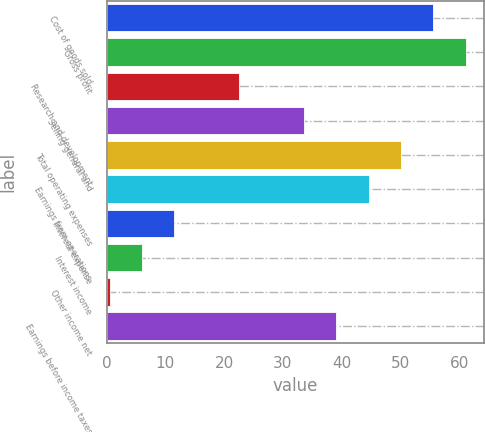<chart> <loc_0><loc_0><loc_500><loc_500><bar_chart><fcel>Cost of goods sold<fcel>Gross profit<fcel>Research and development<fcel>Selling general and<fcel>Total operating expenses<fcel>Earnings from operations<fcel>Interest expense<fcel>Interest income<fcel>Other income net<fcel>Earnings before income taxes<nl><fcel>55.6<fcel>61.11<fcel>22.54<fcel>33.56<fcel>50.09<fcel>44.58<fcel>11.52<fcel>6.01<fcel>0.5<fcel>39.07<nl></chart> 